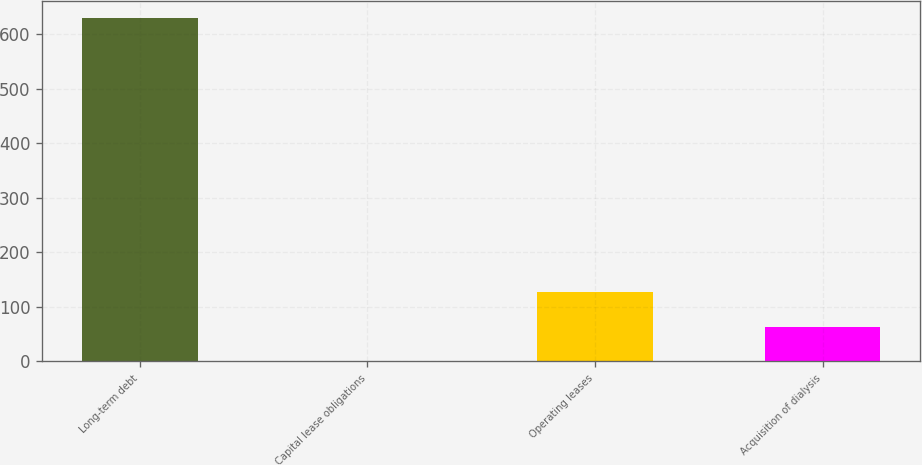Convert chart. <chart><loc_0><loc_0><loc_500><loc_500><bar_chart><fcel>Long-term debt<fcel>Capital lease obligations<fcel>Operating leases<fcel>Acquisition of dialysis<nl><fcel>629<fcel>1<fcel>126.6<fcel>63.8<nl></chart> 